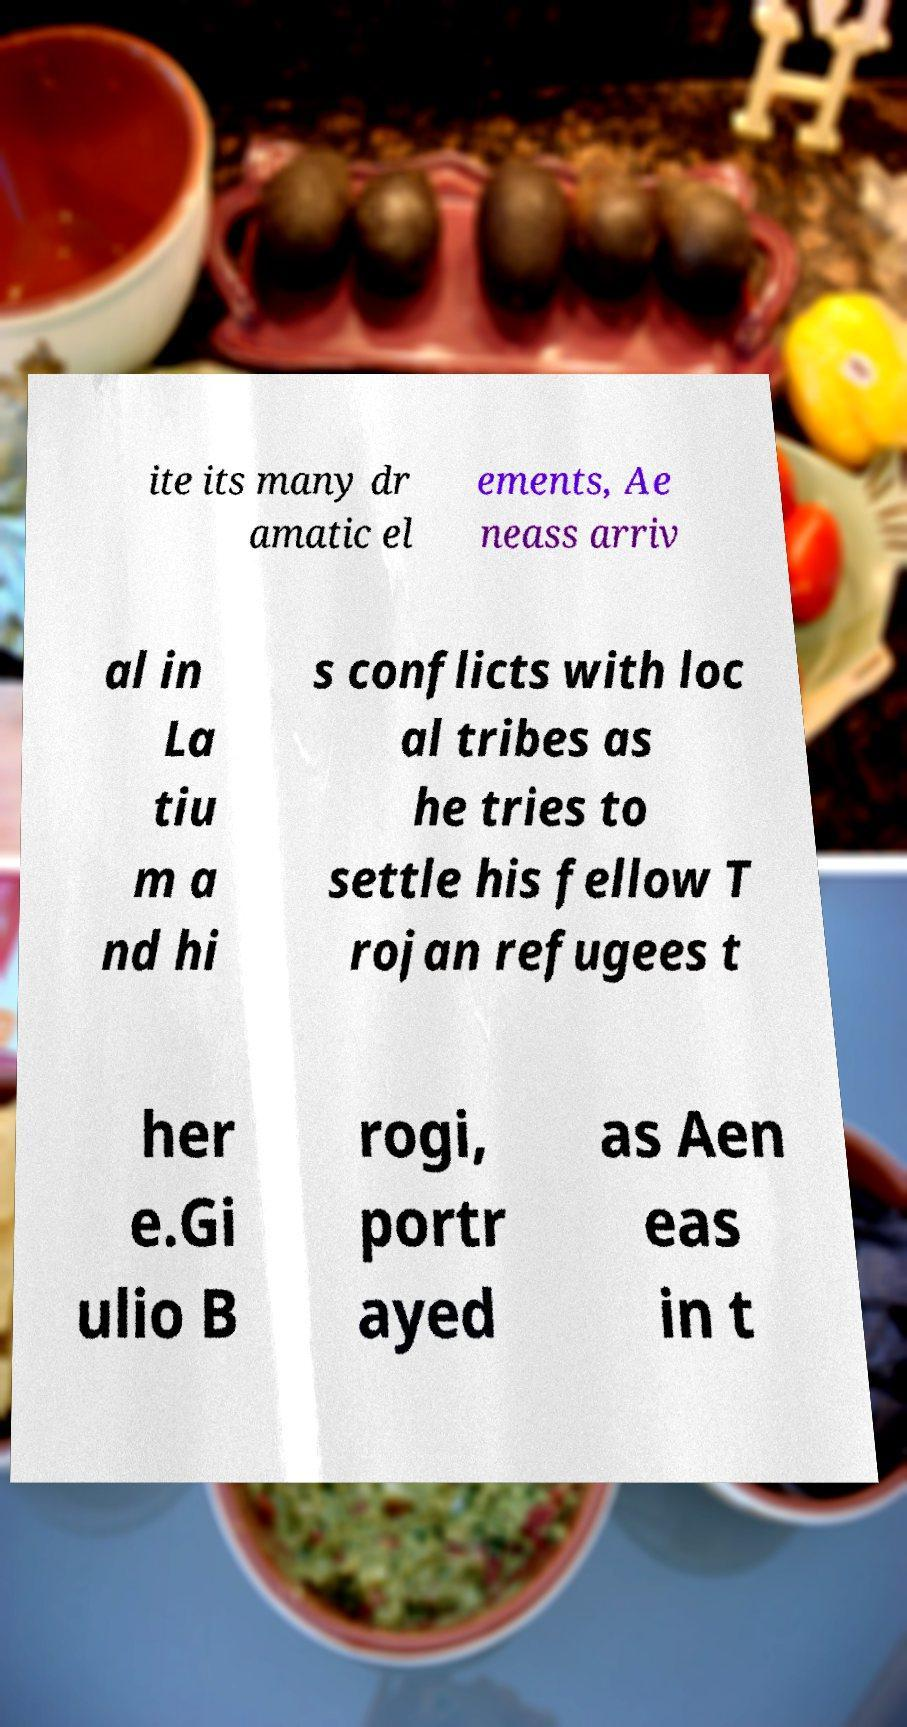Can you read and provide the text displayed in the image?This photo seems to have some interesting text. Can you extract and type it out for me? ite its many dr amatic el ements, Ae neass arriv al in La tiu m a nd hi s conflicts with loc al tribes as he tries to settle his fellow T rojan refugees t her e.Gi ulio B rogi, portr ayed as Aen eas in t 